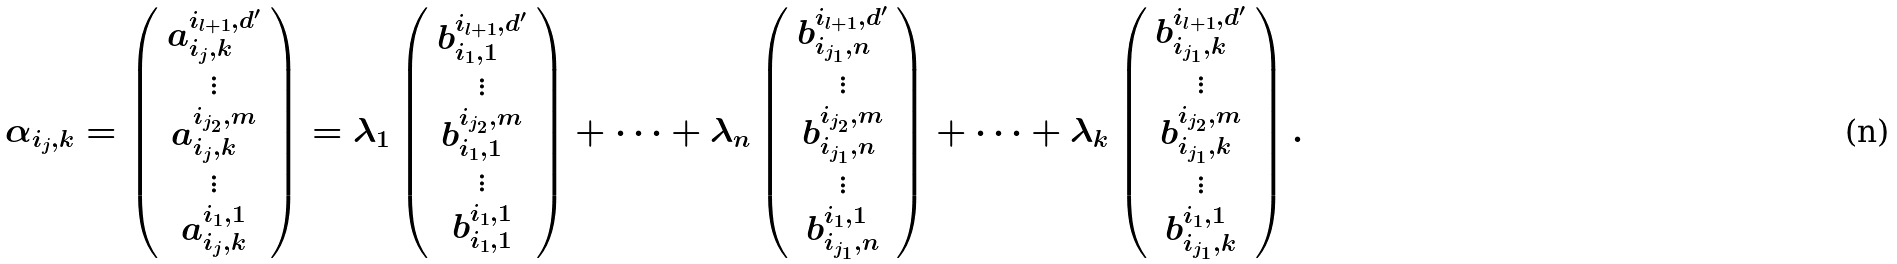Convert formula to latex. <formula><loc_0><loc_0><loc_500><loc_500>\alpha _ { i _ { j } , k } = \left ( \begin{array} { c } a _ { i _ { j } , k } ^ { i _ { l + 1 } , d ^ { \prime } } \\ \vdots \\ a _ { i _ { j } , k } ^ { i _ { j _ { 2 } } , m } \\ \vdots \\ a _ { i _ { j } , k } ^ { i _ { 1 } , 1 } \end{array} \right ) = \lambda _ { 1 } \left ( \begin{array} { c } b _ { i _ { 1 } , 1 } ^ { i _ { l + 1 } , d ^ { \prime } } \\ \vdots \\ b _ { i _ { 1 } , 1 } ^ { i _ { j _ { 2 } } , m } \\ \vdots \\ b _ { i _ { 1 } , 1 } ^ { i _ { 1 } , 1 } \end{array} \right ) + \dots + \lambda _ { n } \left ( \begin{array} { c } b _ { i _ { j _ { 1 } } , n } ^ { i _ { l + 1 } , d ^ { \prime } } \\ \vdots \\ b _ { i _ { j _ { 1 } } , n } ^ { i _ { j _ { 2 } } , m } \\ \vdots \\ b _ { i _ { j _ { 1 } } , n } ^ { i _ { 1 } , 1 } \end{array} \right ) + \dots + \lambda _ { k } \left ( \begin{array} { c } b _ { i _ { j _ { 1 } } , k } ^ { i _ { l + 1 } , d ^ { \prime } } \\ \vdots \\ b _ { i _ { j _ { 1 } } , k } ^ { i _ { j _ { 2 } } , m } \\ \vdots \\ b _ { i _ { j _ { 1 } } , k } ^ { i _ { 1 } , 1 } \end{array} \right ) .</formula> 